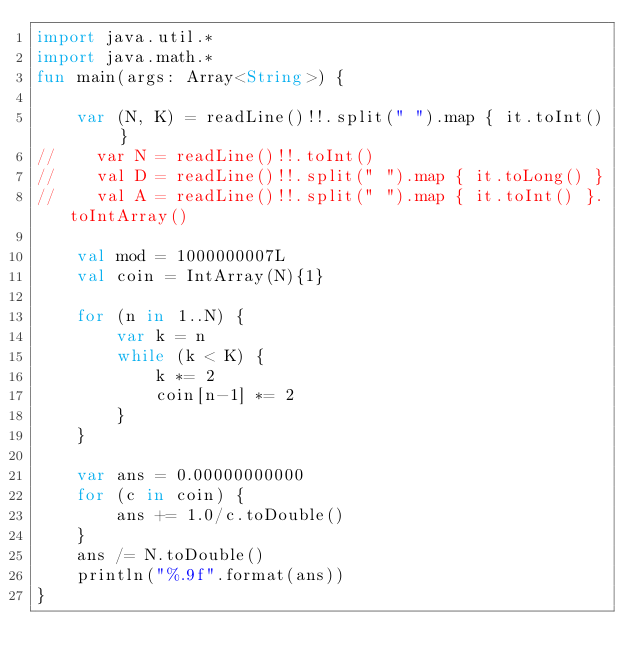<code> <loc_0><loc_0><loc_500><loc_500><_Kotlin_>import java.util.*
import java.math.*
fun main(args: Array<String>) {

    var (N, K) = readLine()!!.split(" ").map { it.toInt() }
//    var N = readLine()!!.toInt()
//    val D = readLine()!!.split(" ").map { it.toLong() }
//    val A = readLine()!!.split(" ").map { it.toInt() }.toIntArray()

    val mod = 1000000007L
    val coin = IntArray(N){1}

    for (n in 1..N) {
        var k = n
        while (k < K) {
            k *= 2
            coin[n-1] *= 2
        }
    }

    var ans = 0.00000000000
    for (c in coin) {
        ans += 1.0/c.toDouble()
    }
    ans /= N.toDouble()
    println("%.9f".format(ans))
}
</code> 